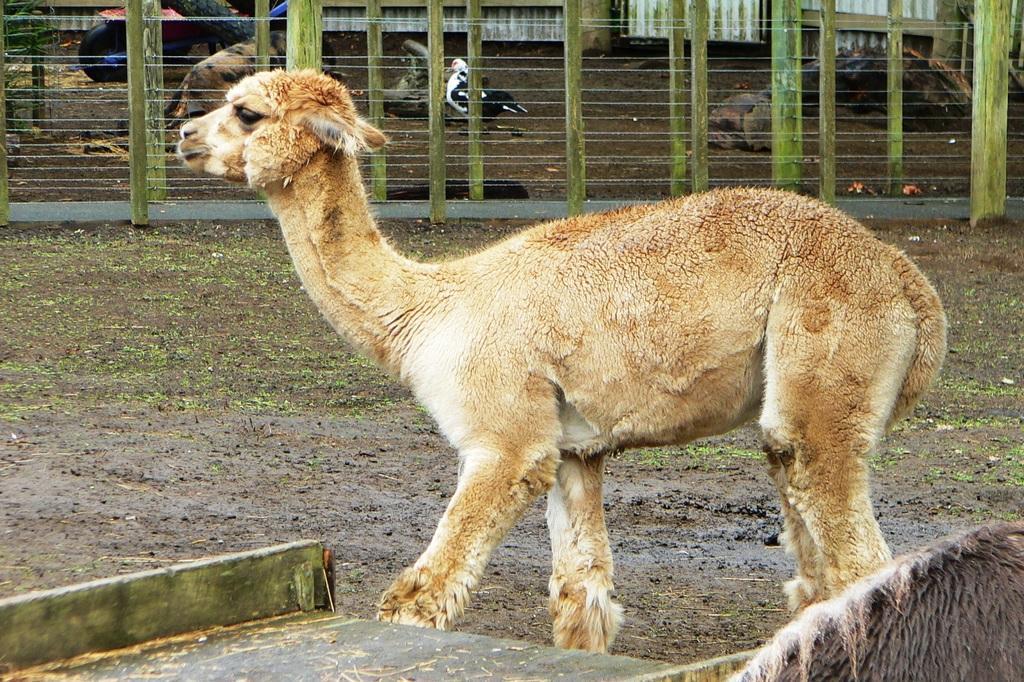How would you summarize this image in a sentence or two? In this image there are animals and a bird. We can see a fence. At the bottom there is a wooden board. 